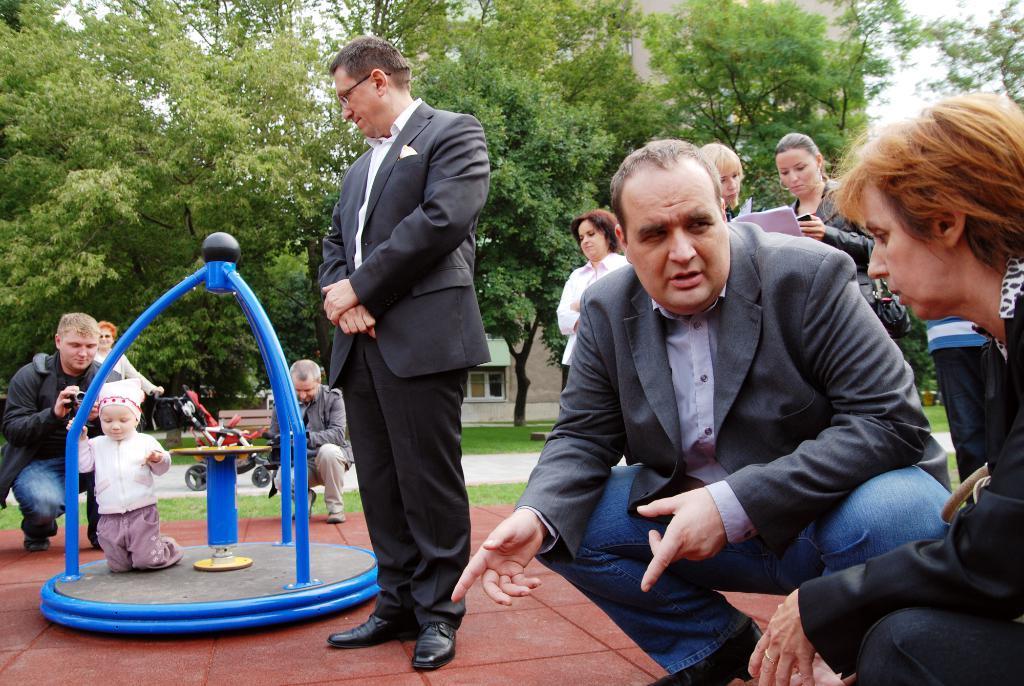How would you summarize this image in a sentence or two? In the image few people are standing and sitting and sitting and holding something in their hands. Behind them there is grass and a person is holding a stroller. At the top of the image there are some trees. Behind the trees there is a building. 